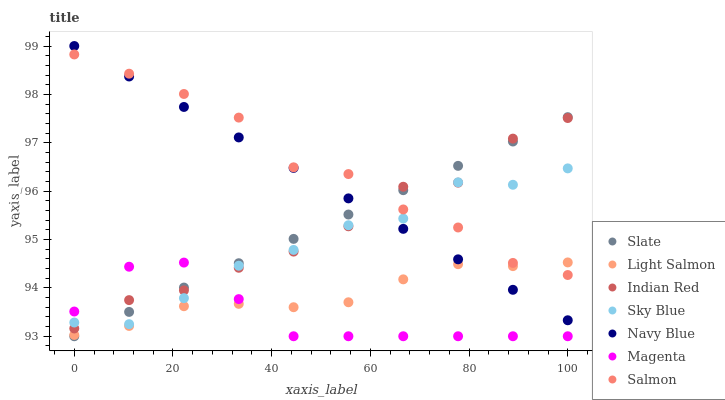Does Magenta have the minimum area under the curve?
Answer yes or no. Yes. Does Salmon have the maximum area under the curve?
Answer yes or no. Yes. Does Navy Blue have the minimum area under the curve?
Answer yes or no. No. Does Navy Blue have the maximum area under the curve?
Answer yes or no. No. Is Navy Blue the smoothest?
Answer yes or no. Yes. Is Sky Blue the roughest?
Answer yes or no. Yes. Is Slate the smoothest?
Answer yes or no. No. Is Slate the roughest?
Answer yes or no. No. Does Slate have the lowest value?
Answer yes or no. Yes. Does Navy Blue have the lowest value?
Answer yes or no. No. Does Navy Blue have the highest value?
Answer yes or no. Yes. Does Slate have the highest value?
Answer yes or no. No. Is Magenta less than Salmon?
Answer yes or no. Yes. Is Sky Blue greater than Light Salmon?
Answer yes or no. Yes. Does Salmon intersect Slate?
Answer yes or no. Yes. Is Salmon less than Slate?
Answer yes or no. No. Is Salmon greater than Slate?
Answer yes or no. No. Does Magenta intersect Salmon?
Answer yes or no. No. 